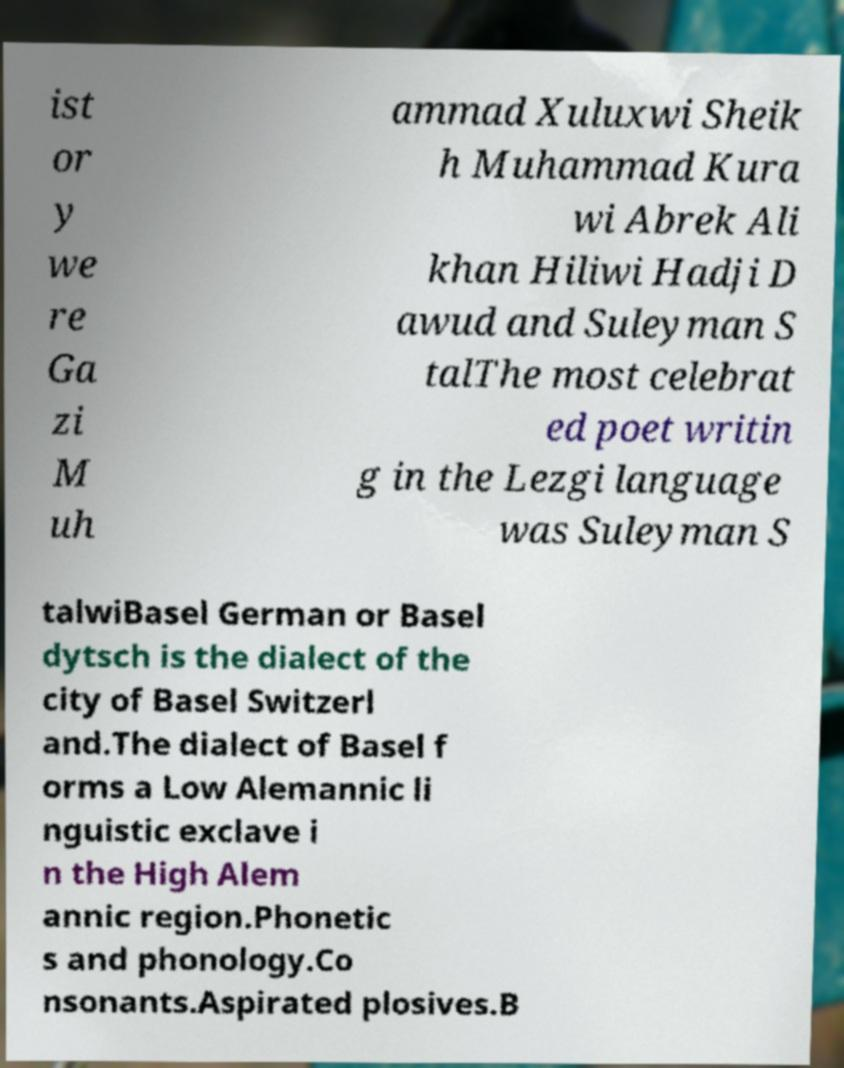Can you read and provide the text displayed in the image?This photo seems to have some interesting text. Can you extract and type it out for me? ist or y we re Ga zi M uh ammad Xuluxwi Sheik h Muhammad Kura wi Abrek Ali khan Hiliwi Hadji D awud and Suleyman S talThe most celebrat ed poet writin g in the Lezgi language was Suleyman S talwiBasel German or Basel dytsch is the dialect of the city of Basel Switzerl and.The dialect of Basel f orms a Low Alemannic li nguistic exclave i n the High Alem annic region.Phonetic s and phonology.Co nsonants.Aspirated plosives.B 